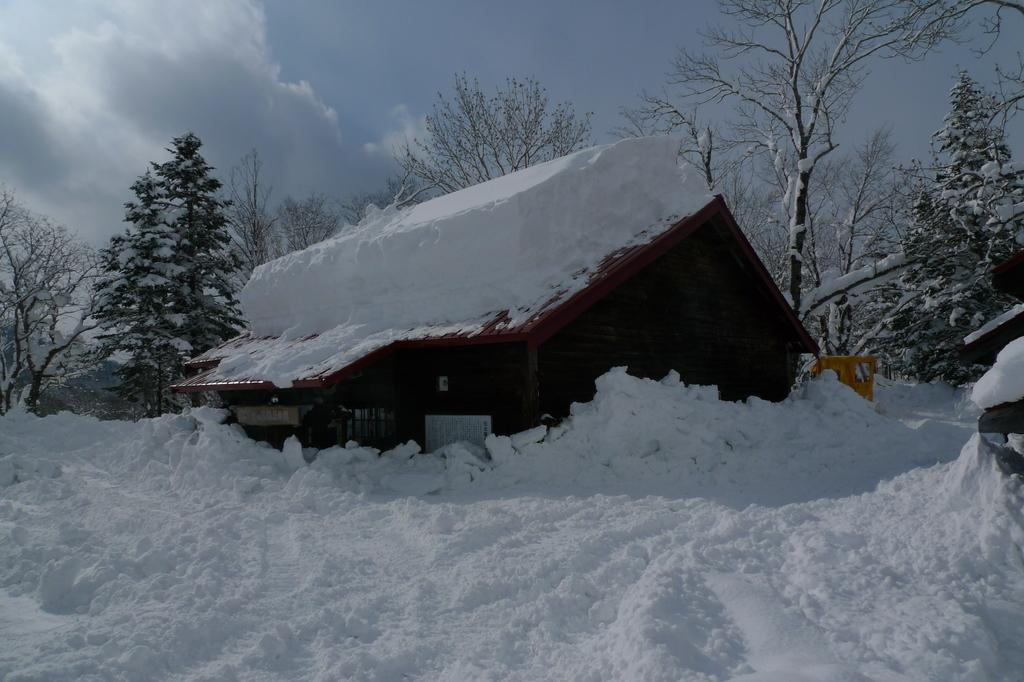What type of structure is present in the image? There is a house in the image. What other natural elements can be seen in the image? There are trees in the image. What is the weather condition in the image? There is snow visible in the image, indicating a cold or wintery condition. What is visible in the background of the image? The sky is visible in the background of the image. What type of plant is growing on the chin of the person in the image? There is no person present in the image, and therefore no chin or plant growing on it. 